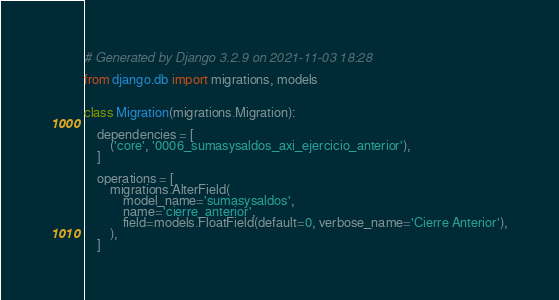<code> <loc_0><loc_0><loc_500><loc_500><_Python_># Generated by Django 3.2.9 on 2021-11-03 18:28

from django.db import migrations, models


class Migration(migrations.Migration):

    dependencies = [
        ('core', '0006_sumasysaldos_axi_ejercicio_anterior'),
    ]

    operations = [
        migrations.AlterField(
            model_name='sumasysaldos',
            name='cierre_anterior',
            field=models.FloatField(default=0, verbose_name='Cierre Anterior'),
        ),
    ]
</code> 